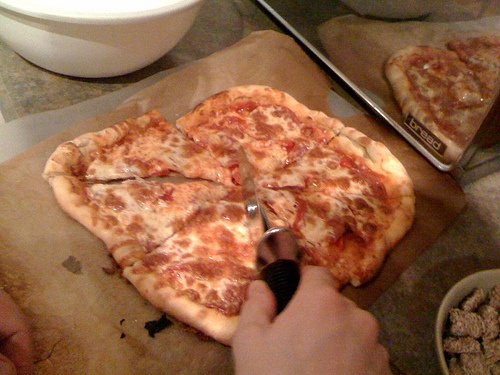Describe the objects in this image and their specific colors. I can see pizza in beige, tan, brown, salmon, and red tones, bowl in beige, gray, ivory, and tan tones, people in beige, salmon, brown, and maroon tones, pizza in beige, maroon, brown, and gray tones, and bowl in beige, maroon, black, and gray tones in this image. 